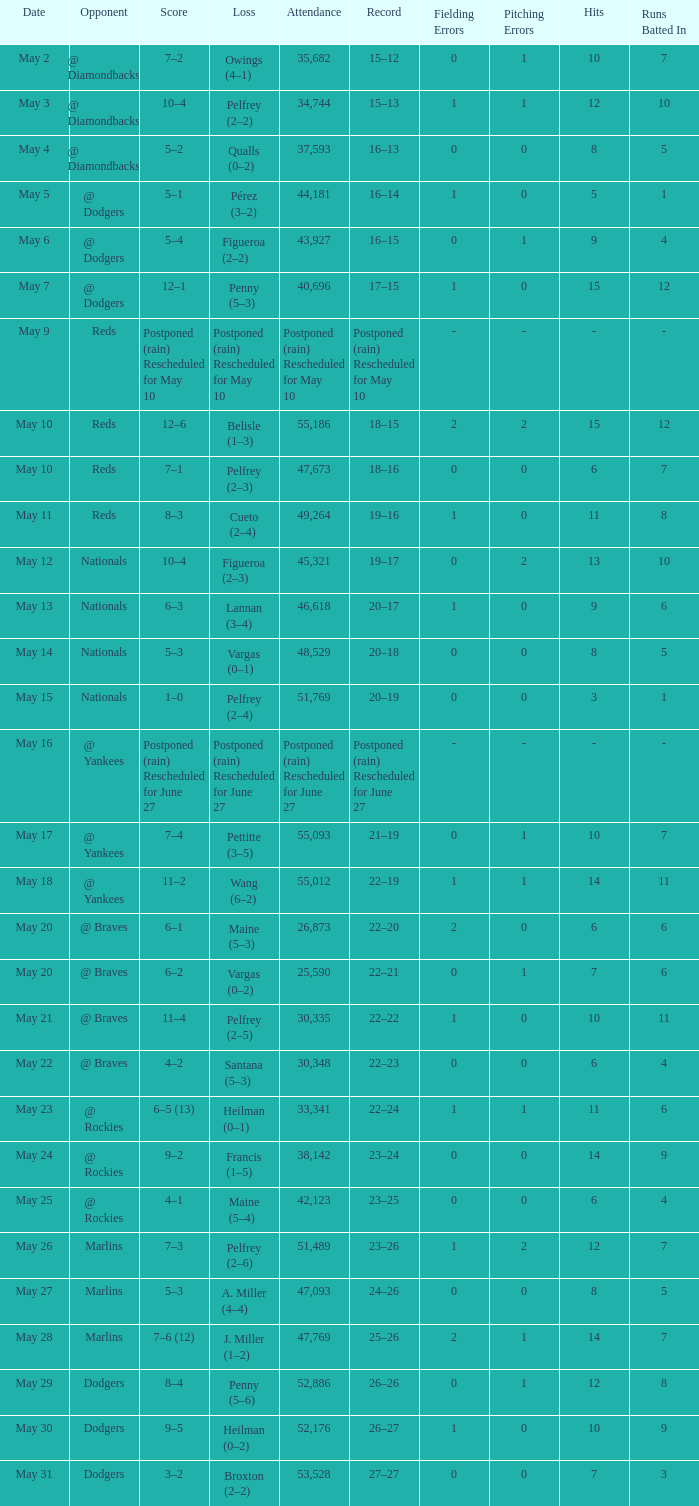Record of 19–16 occurred on what date? May 11. 